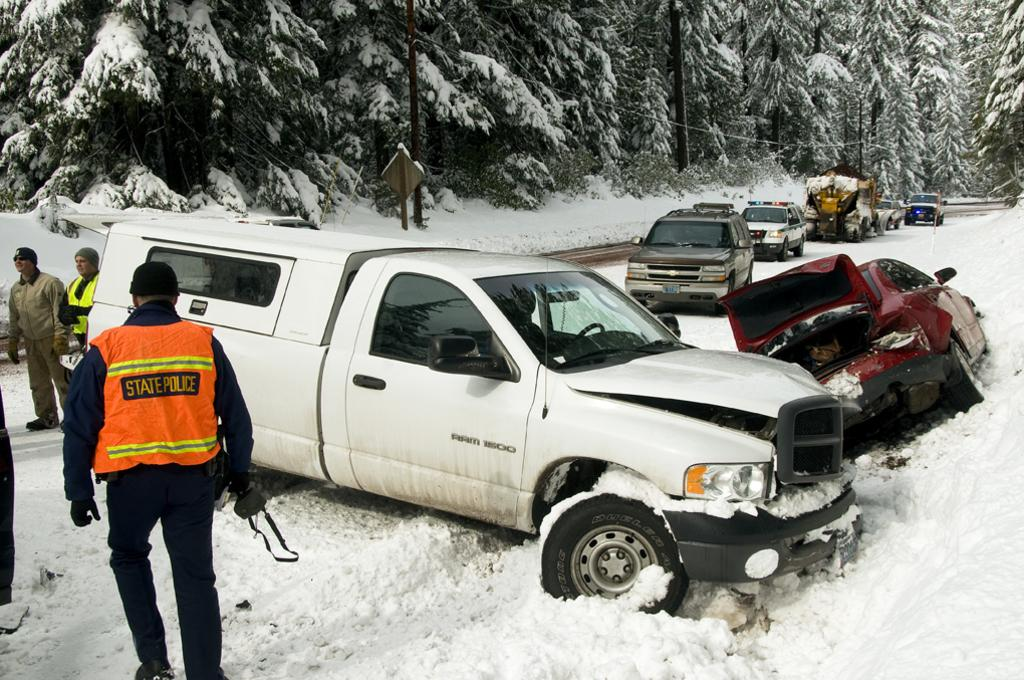What color is the vehicle in the image? The vehicle in the image is white. What is the occupation of the person walking in the image? The person walking is a policeman. What color is the policeman's coat? The policeman's coat is orange. What type of vegetation is present in the image? There are trees in the image. What is the weather condition in the image? The weather condition in the image is snowy, as there is snow on the trees. How many eggs are being kicked by the policeman in the image? There are no eggs present in the image, nor is the policeman kicking anything. 